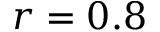<formula> <loc_0><loc_0><loc_500><loc_500>r = 0 . 8</formula> 